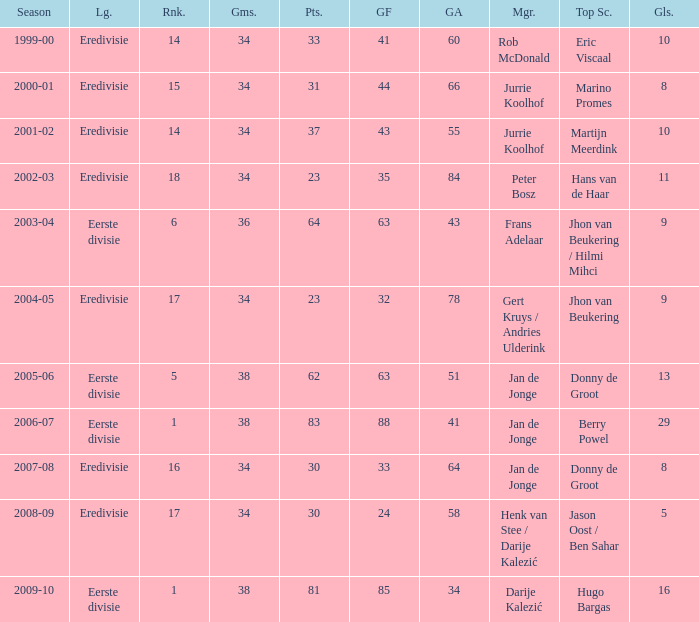Who is the manager whose rank is 16? Jan de Jonge. 